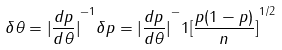<formula> <loc_0><loc_0><loc_500><loc_500>\delta \theta = { | \frac { d p } { d \theta } | } ^ { - 1 } \delta p = { | \frac { d p } { d \theta } | } ^ { - } 1 { [ \frac { p ( 1 - p ) } { n } ] } ^ { 1 / 2 }</formula> 